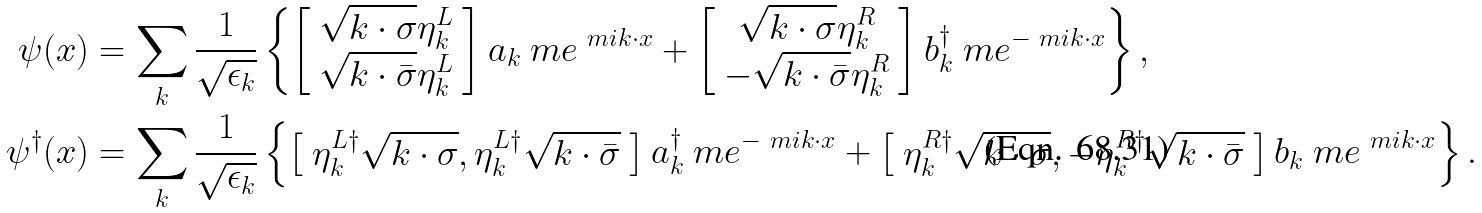Convert formula to latex. <formula><loc_0><loc_0><loc_500><loc_500>\psi ( x ) & = \sum _ { k } \frac { 1 } { \sqrt { \epsilon _ { k } } } \left \{ \left [ \begin{array} { c c c } \sqrt { k \cdot \sigma } \eta ^ { L } _ { k } \\ \sqrt { k \cdot \bar { \sigma } } \eta ^ { L } _ { k } \end{array} \right ] a _ { k } \ m e ^ { \ m i k \cdot x } + \left [ \begin{array} { c c c } \sqrt { k \cdot \sigma } \eta ^ { R } _ { k } \\ - \sqrt { k \cdot \bar { \sigma } } \eta ^ { R } _ { k } \end{array} \right ] b ^ { \dagger } _ { k } \ m e ^ { - \ m i k \cdot x } \right \} , \\ \psi ^ { \dagger } ( x ) & = \sum _ { k } \frac { 1 } { \sqrt { \epsilon _ { k } } } \left \{ \left [ \begin{array} { l } \eta ^ { L \dagger } _ { k } \sqrt { k \cdot \sigma } , \eta ^ { L \dagger } _ { k } \sqrt { k \cdot \bar { \sigma } } \end{array} \right ] a ^ { \dagger } _ { k } \ m e ^ { - \ m i k \cdot x } + \left [ \begin{array} { l } \eta ^ { R \dagger } _ { k } \sqrt { k \cdot \sigma } , - \eta ^ { R \dagger } _ { k } \sqrt { k \cdot \bar { \sigma } } \end{array} \right ] b _ { k } \ m e ^ { \ m i k \cdot x } \right \} .</formula> 